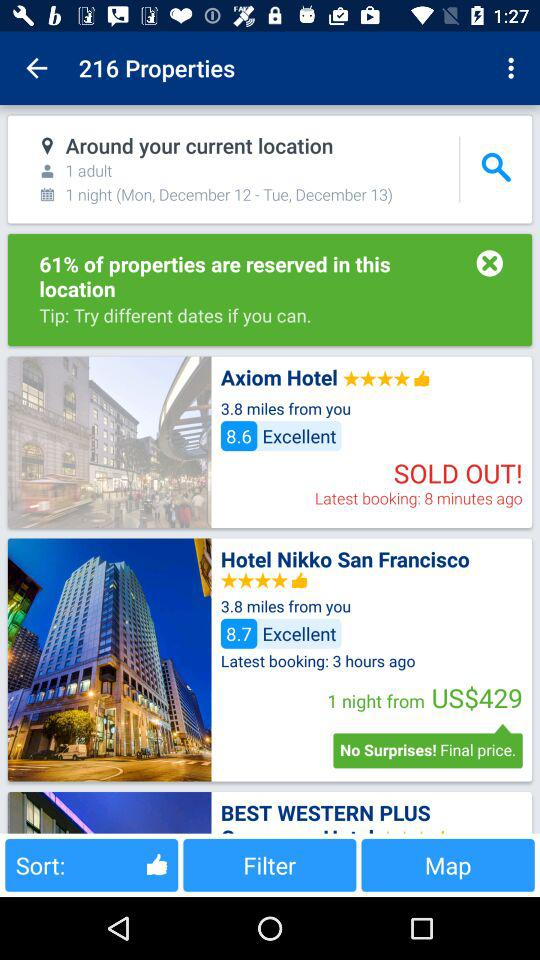How much of the property is reserved? The reserved property is 61%. 